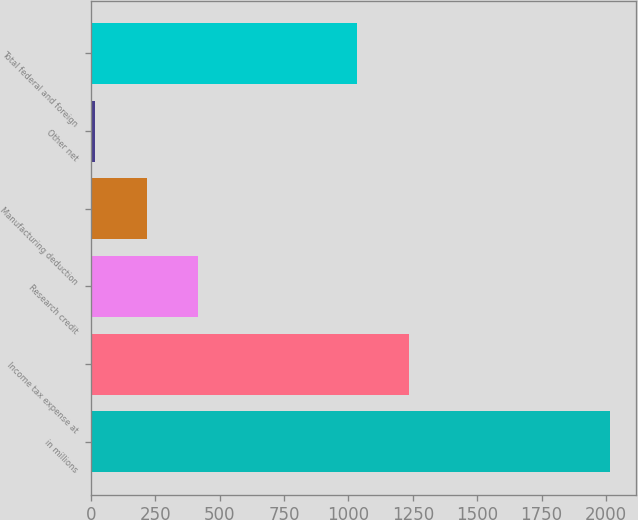Convert chart to OTSL. <chart><loc_0><loc_0><loc_500><loc_500><bar_chart><fcel>in millions<fcel>Income tax expense at<fcel>Research credit<fcel>Manufacturing deduction<fcel>Other net<fcel>Total federal and foreign<nl><fcel>2017<fcel>1234.1<fcel>416.2<fcel>216.1<fcel>16<fcel>1034<nl></chart> 